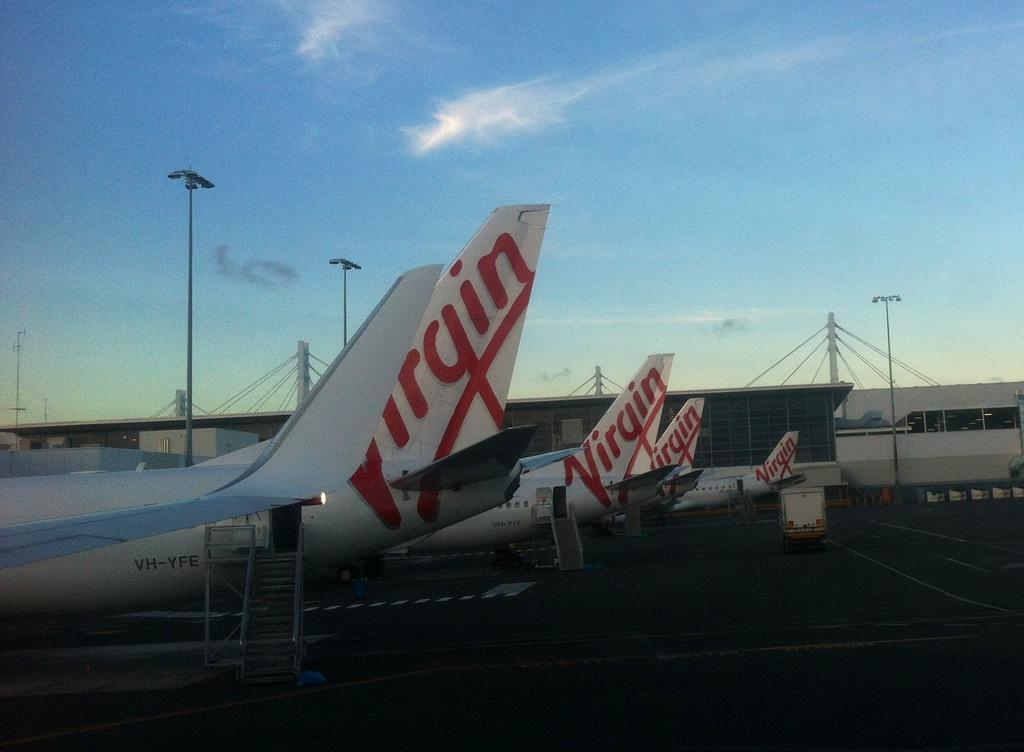What can be seen on the left side of the image? There are flights on the left side of the image. What is present on the road in the image? There is a vehicle on the road in the image. What is located in the background of the image? There is an airport in the background of the image. What is visible in the sky in the image? The sky is visible in the background of the image. What flavor of ice cream is being sold at the shop in the image? There is no shop present in the image, so it is not possible to determine the flavor of ice cream being sold. 